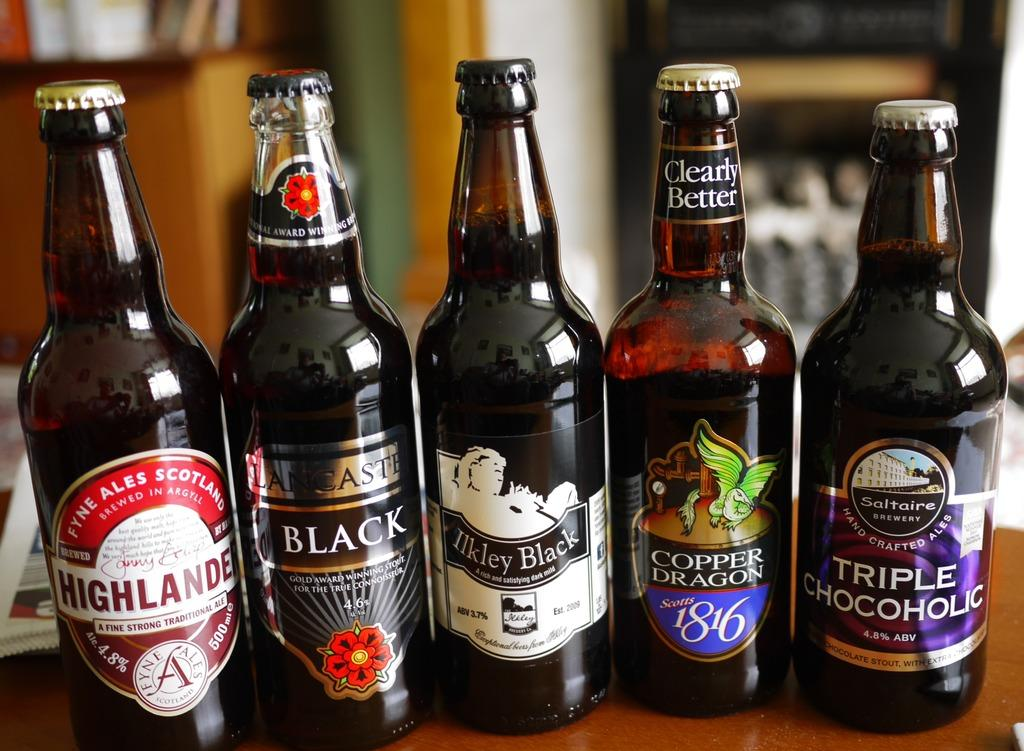What types of objects are present in the image? There are different types of bottles in the image. Can you see a plough being used in the image? There is no plough present in the image. What type of bean is growing in the image? There is no bean present in the image. 